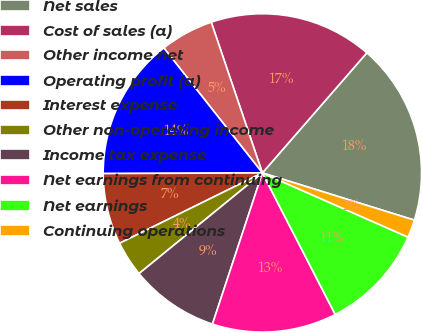<chart> <loc_0><loc_0><loc_500><loc_500><pie_chart><fcel>Net sales<fcel>Cost of sales (a)<fcel>Other income net<fcel>Operating profit (a)<fcel>Interest expense<fcel>Other non-operating income<fcel>Income tax expense<fcel>Net earnings from continuing<fcel>Net earnings<fcel>Continuing operations<nl><fcel>18.4%<fcel>16.6%<fcel>5.42%<fcel>14.44%<fcel>7.22%<fcel>3.61%<fcel>9.03%<fcel>12.64%<fcel>10.83%<fcel>1.81%<nl></chart> 